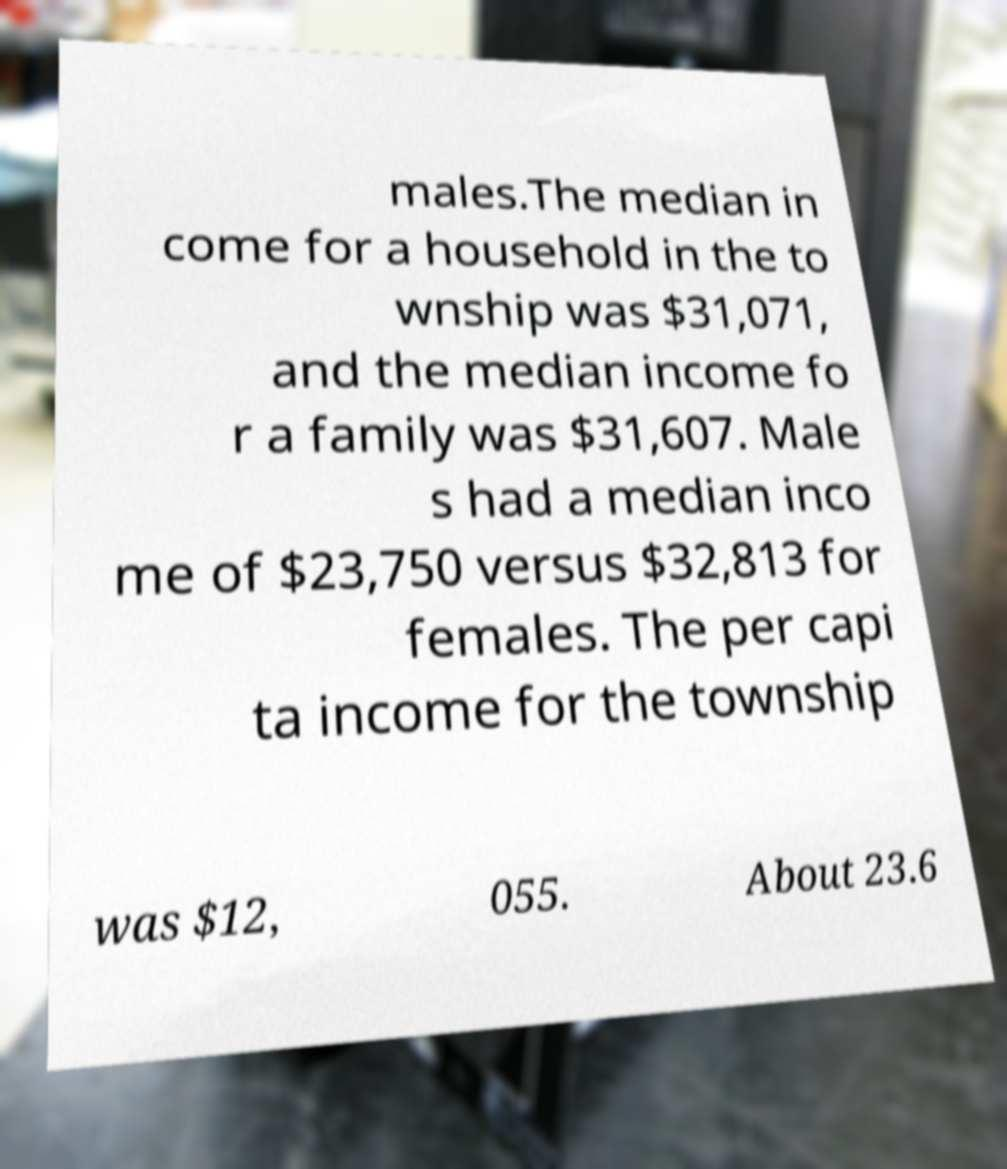What messages or text are displayed in this image? I need them in a readable, typed format. males.The median in come for a household in the to wnship was $31,071, and the median income fo r a family was $31,607. Male s had a median inco me of $23,750 versus $32,813 for females. The per capi ta income for the township was $12, 055. About 23.6 